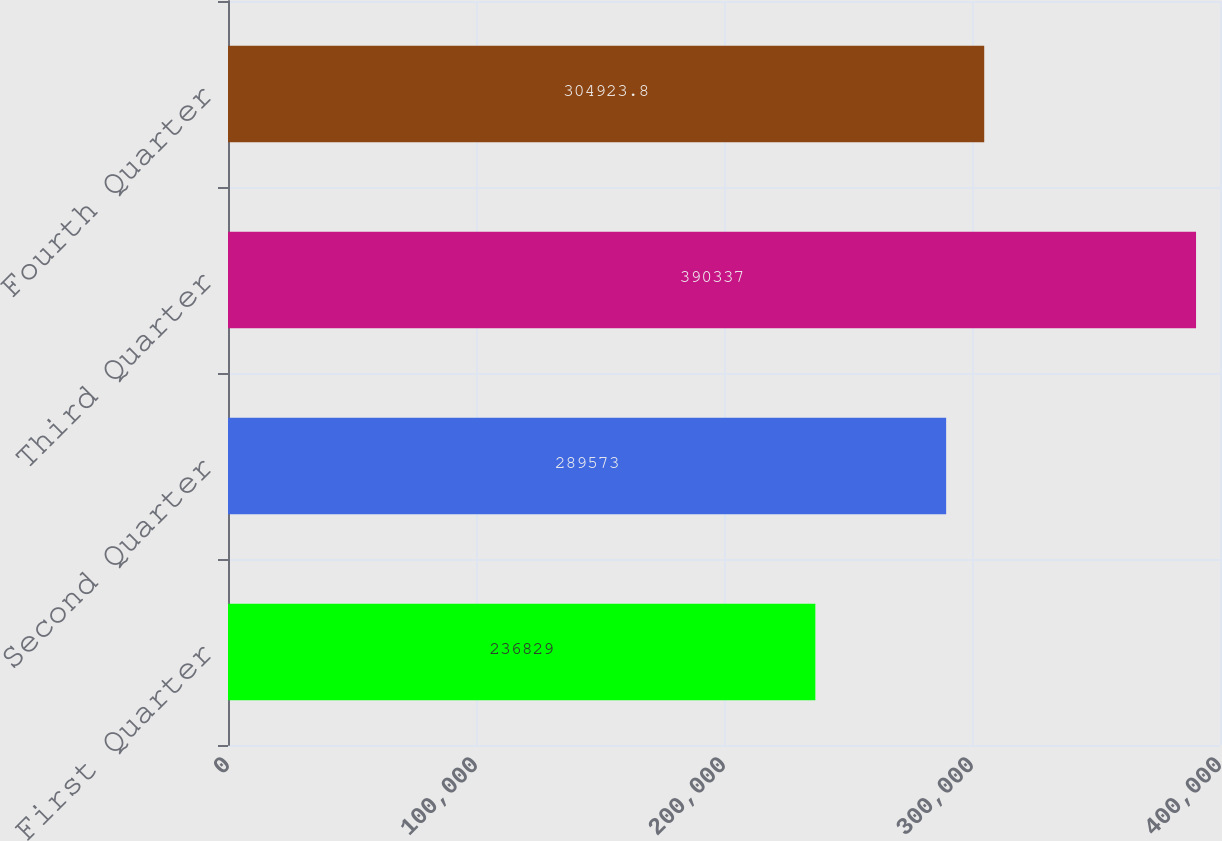Convert chart to OTSL. <chart><loc_0><loc_0><loc_500><loc_500><bar_chart><fcel>First Quarter<fcel>Second Quarter<fcel>Third Quarter<fcel>Fourth Quarter<nl><fcel>236829<fcel>289573<fcel>390337<fcel>304924<nl></chart> 